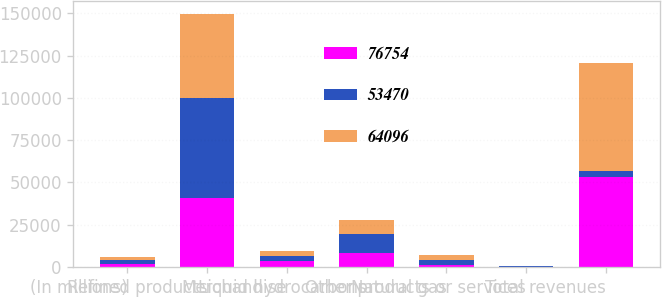Convert chart. <chart><loc_0><loc_0><loc_500><loc_500><stacked_bar_chart><ecel><fcel>(In millions)<fcel>Refined products<fcel>Merchandise<fcel>Liquid hydrocarbons<fcel>Natural gas<fcel>Other products or services<fcel>Total revenues<nl><fcel>76754<fcel>2009<fcel>40518<fcel>3308<fcel>8253<fcel>1265<fcel>126<fcel>53470<nl><fcel>53470<fcel>2008<fcel>59299<fcel>3028<fcel>10983<fcel>3085<fcel>359<fcel>3056.5<nl><fcel>64096<fcel>2007<fcel>49718<fcel>2975<fcel>8463<fcel>2629<fcel>311<fcel>64096<nl></chart> 